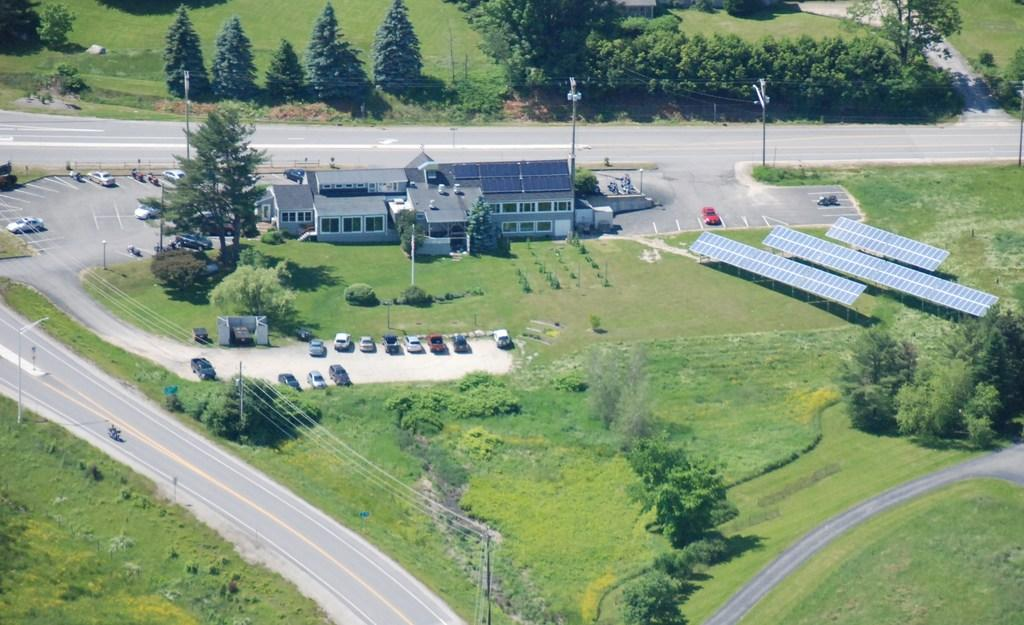What type of view is shown in the image? The image is an aerial view. What can be seen on the ground in the image? There are roads, grass, trees, houses, and vehicles parked in the image. Are there any energy-efficient features visible in the image? Yes, solar panels are visible in the image. What else can be seen in the image that provides light? Light poles are present in the image. What type of wine is being served at the queen's table in the image? There is no queen, table, or wine present in the image. 